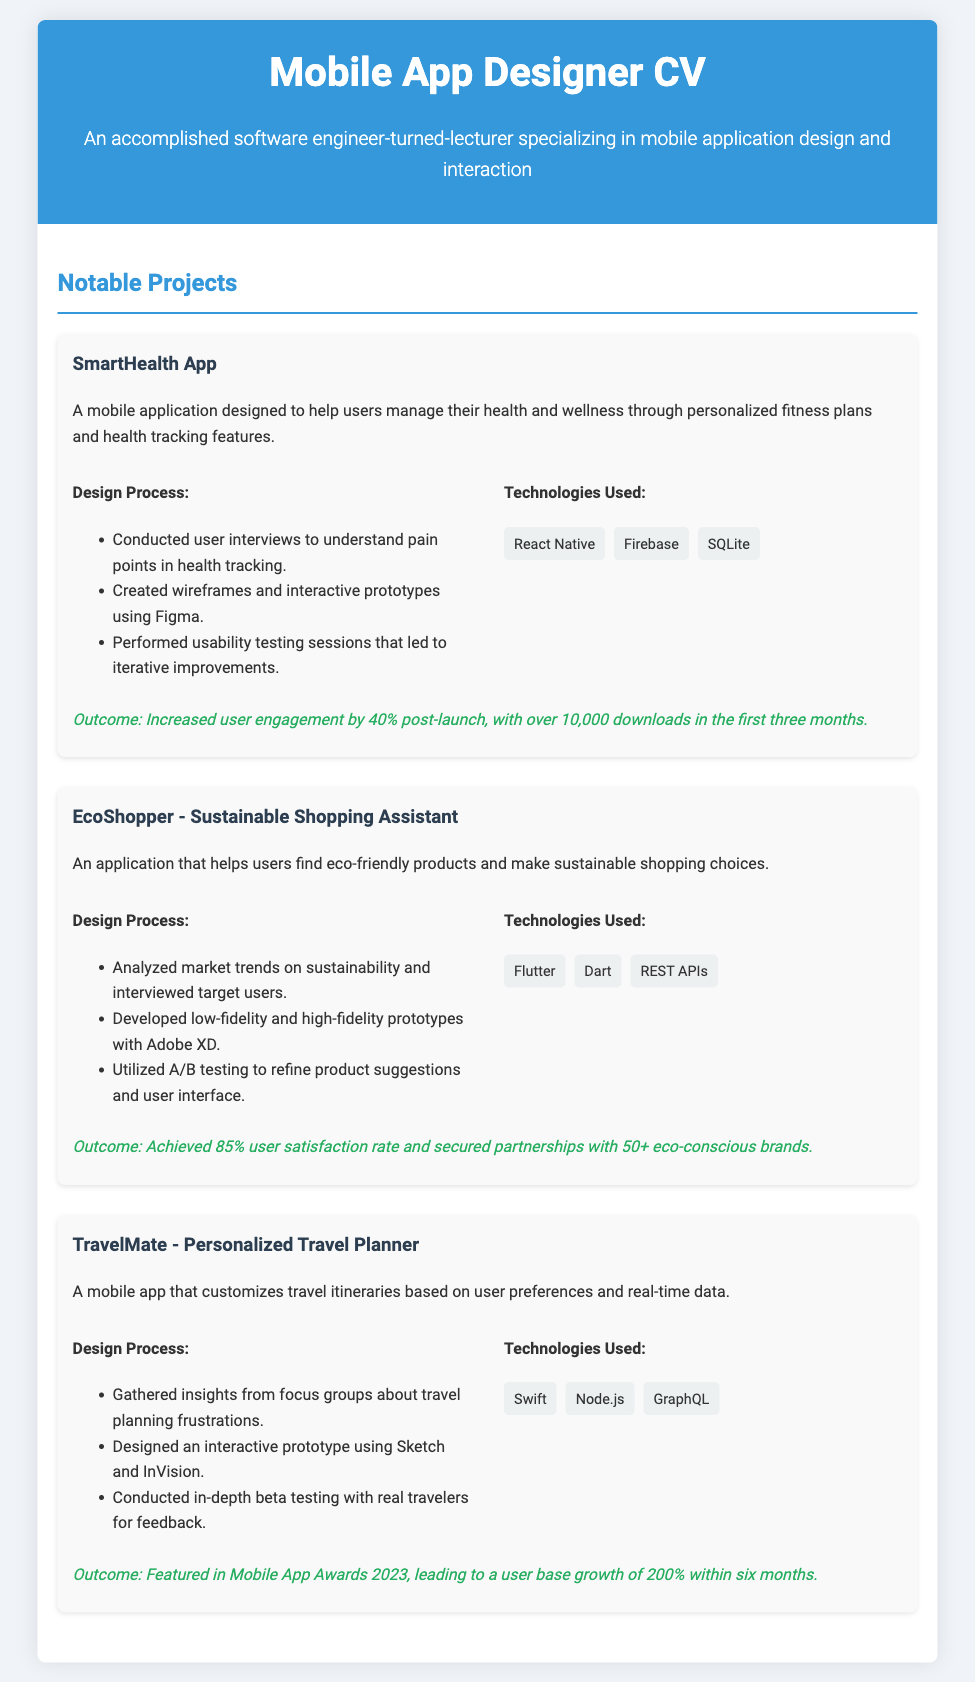What is the name of the first project? The first project listed is the SmartHealth App.
Answer: SmartHealth App What technology was used in the EcoShopper project? The EcoShopper project utilized Flutter.
Answer: Flutter What was the outcome of the SmartHealth App? The outcome mentioned for the SmartHealth App is an increase in user engagement by 40%.
Answer: Increased user engagement by 40% What design tool was used for the TravelMate prototype? The design tool used for creating the TravelMate interactive prototype is Sketch.
Answer: Sketch How many eco-conscious brands partnered with EcoShopper? The document states that EcoShopper secured partnerships with over 50 brands.
Answer: 50+ What did feedback from real travelers help improve? Feedback from real travelers helped improve the TravelMate app during beta testing.
Answer: TravelMate app What percentage of user satisfaction did EcoShopper achieve? The EcoShopper app achieved an 85% user satisfaction rate.
Answer: 85% When was the TravelMate featured in the Mobile App Awards? The TravelMate was featured in Mobile App Awards 2023.
Answer: 2023 How many downloads did SmartHealth App achieve in the first three months? The SmartHealth App achieved over 10,000 downloads in the first three months.
Answer: 10,000 